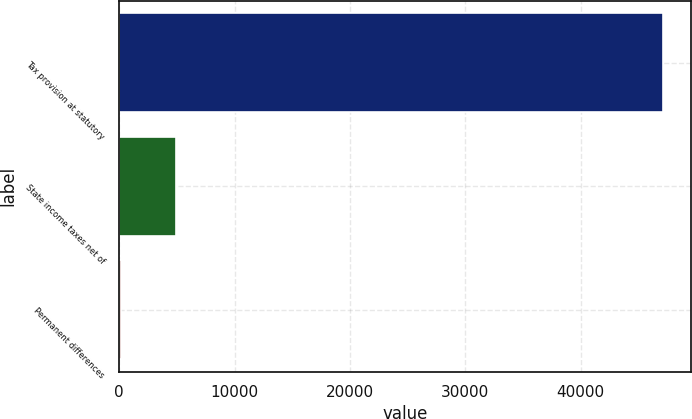Convert chart to OTSL. <chart><loc_0><loc_0><loc_500><loc_500><bar_chart><fcel>Tax provision at statutory<fcel>State income taxes net of<fcel>Permanent differences<nl><fcel>47173<fcel>4888.3<fcel>190<nl></chart> 